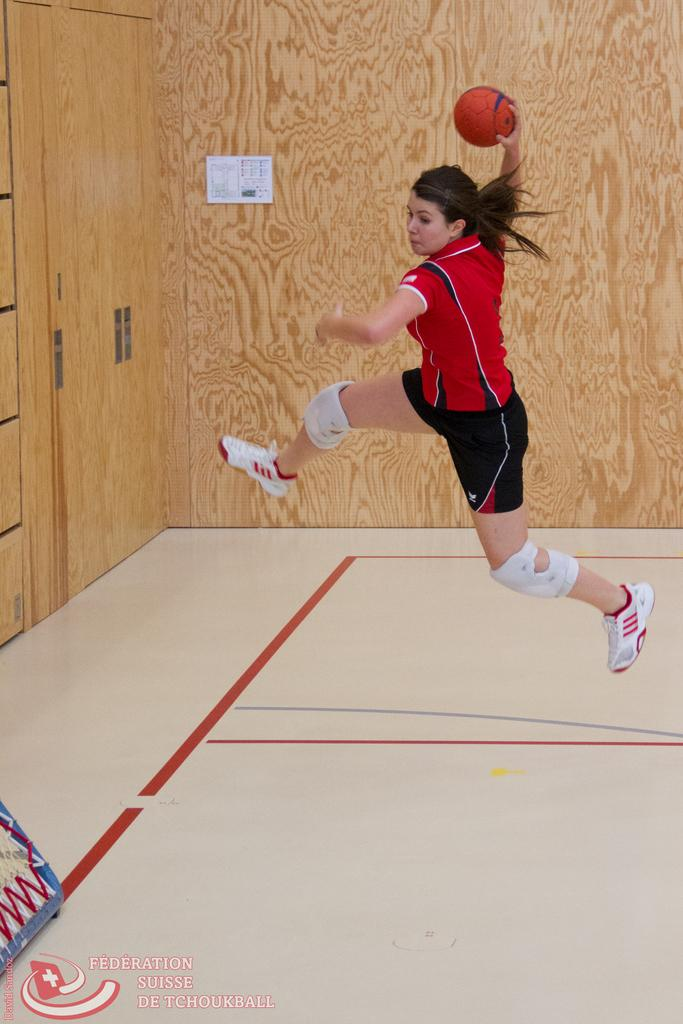Who is present in the image? There is a woman in the image. What is the woman holding in the image? The woman is holding a ball. What is the woman wearing in the image? The woman is wearing a red T-shirt. What can be seen in the background of the image? There are wooden walls in the background of the image. What type of bird can be seen flying in the image? There is no bird present in the image; it only features a woman holding a ball and wooden walls in the background. 